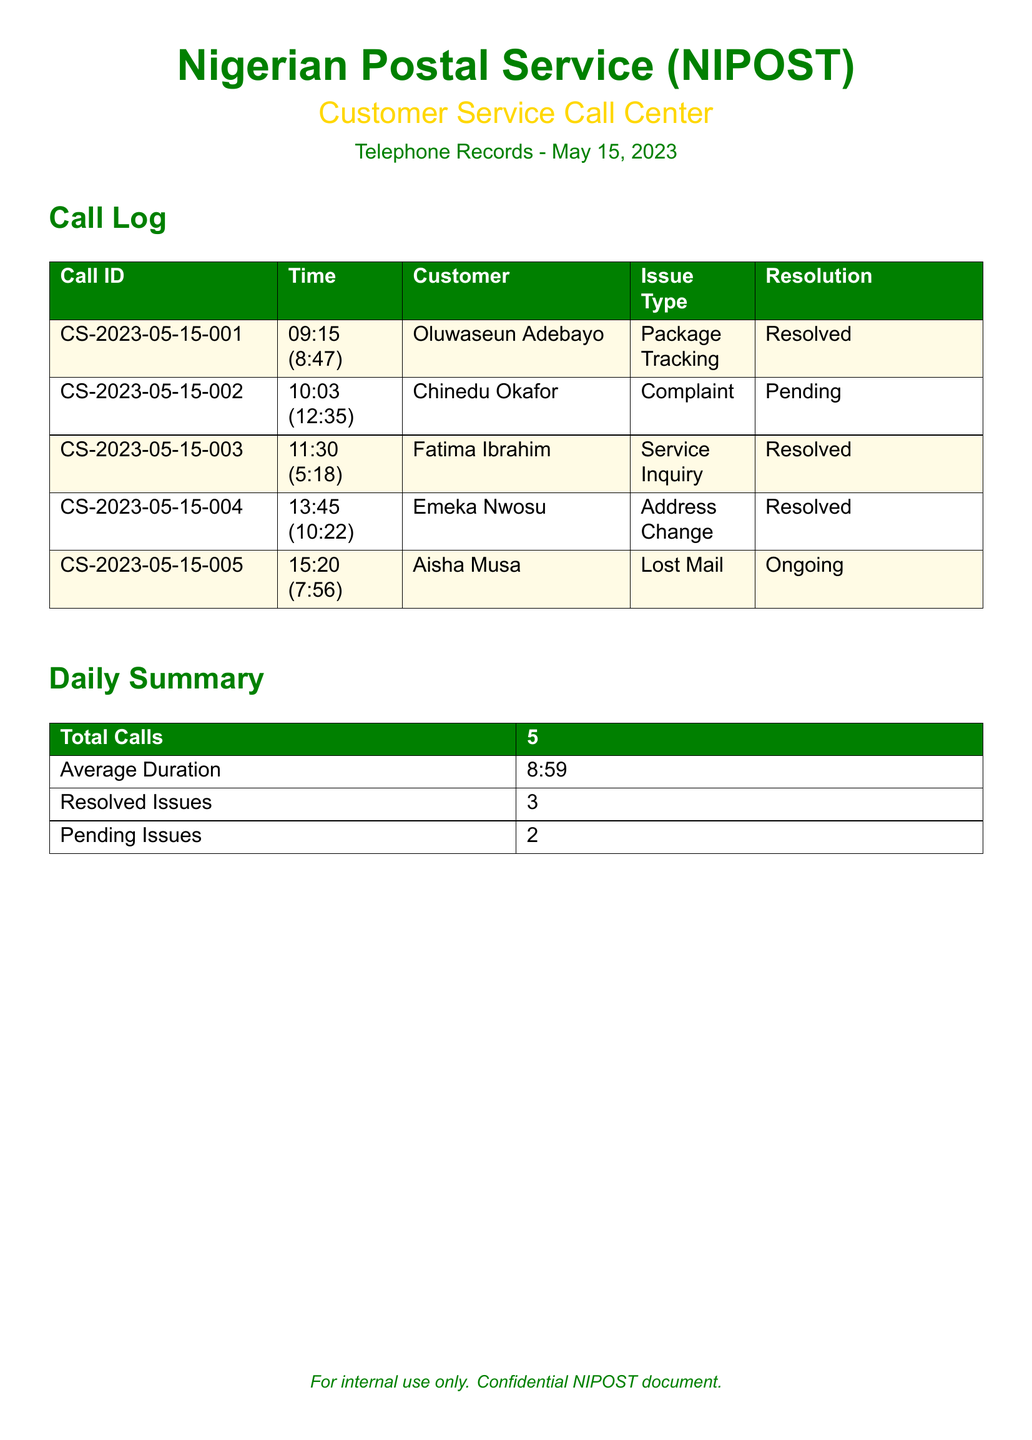What is the date of the call log? The date of the call log is specified in the document header.
Answer: May 15, 2023 How many total calls were recorded? The total number of calls is summarized in the Daily Summary section.
Answer: 5 What was the average duration of the calls? The average duration can be found in the Daily Summary section of the document.
Answer: 8:59 Who was the customer in the second call? The customer's name for the second call is listed in the Call Log.
Answer: Chinedu Okafor What was the resolution status of the lost mail issue? The resolution status is reported in the Call Log related to the lost mail call.
Answer: Ongoing How many issues were resolved? The number of resolved issues can be found in the Daily Summary section.
Answer: 3 What type of issue was reported by Oluwaseun Adebayo? The issue type reported by the first customer is listed in the Call Log.
Answer: Package Tracking Which customer had a pending issue? The call log indicates which customer's issue is pending.
Answer: Chinedu Okafor What was the call duration for the third call? The call duration for the third customer is specified in the Call Log.
Answer: 5:18 